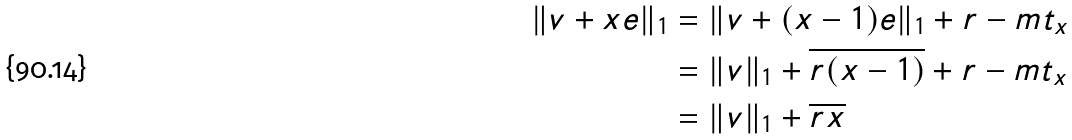<formula> <loc_0><loc_0><loc_500><loc_500>\| { v } + x { e } \| _ { 1 } & = \| { v } + ( x - 1 ) { e } \| _ { 1 } + r - m t _ { x } \\ & = \| { v } \| _ { 1 } + \overline { r ( x - 1 ) } + r - m t _ { x } \\ & = \| { v } \| _ { 1 } + \overline { r x }</formula> 